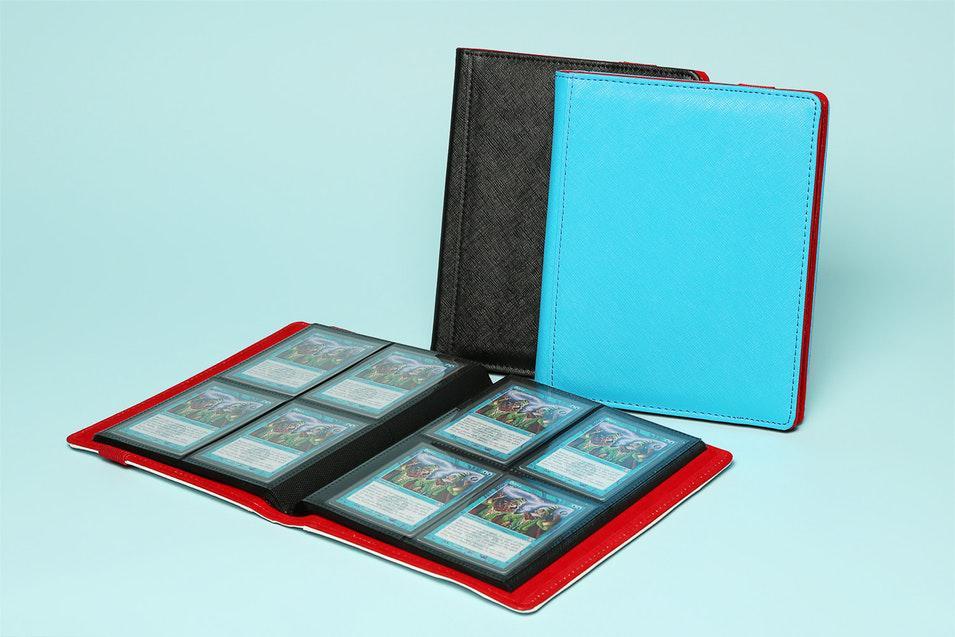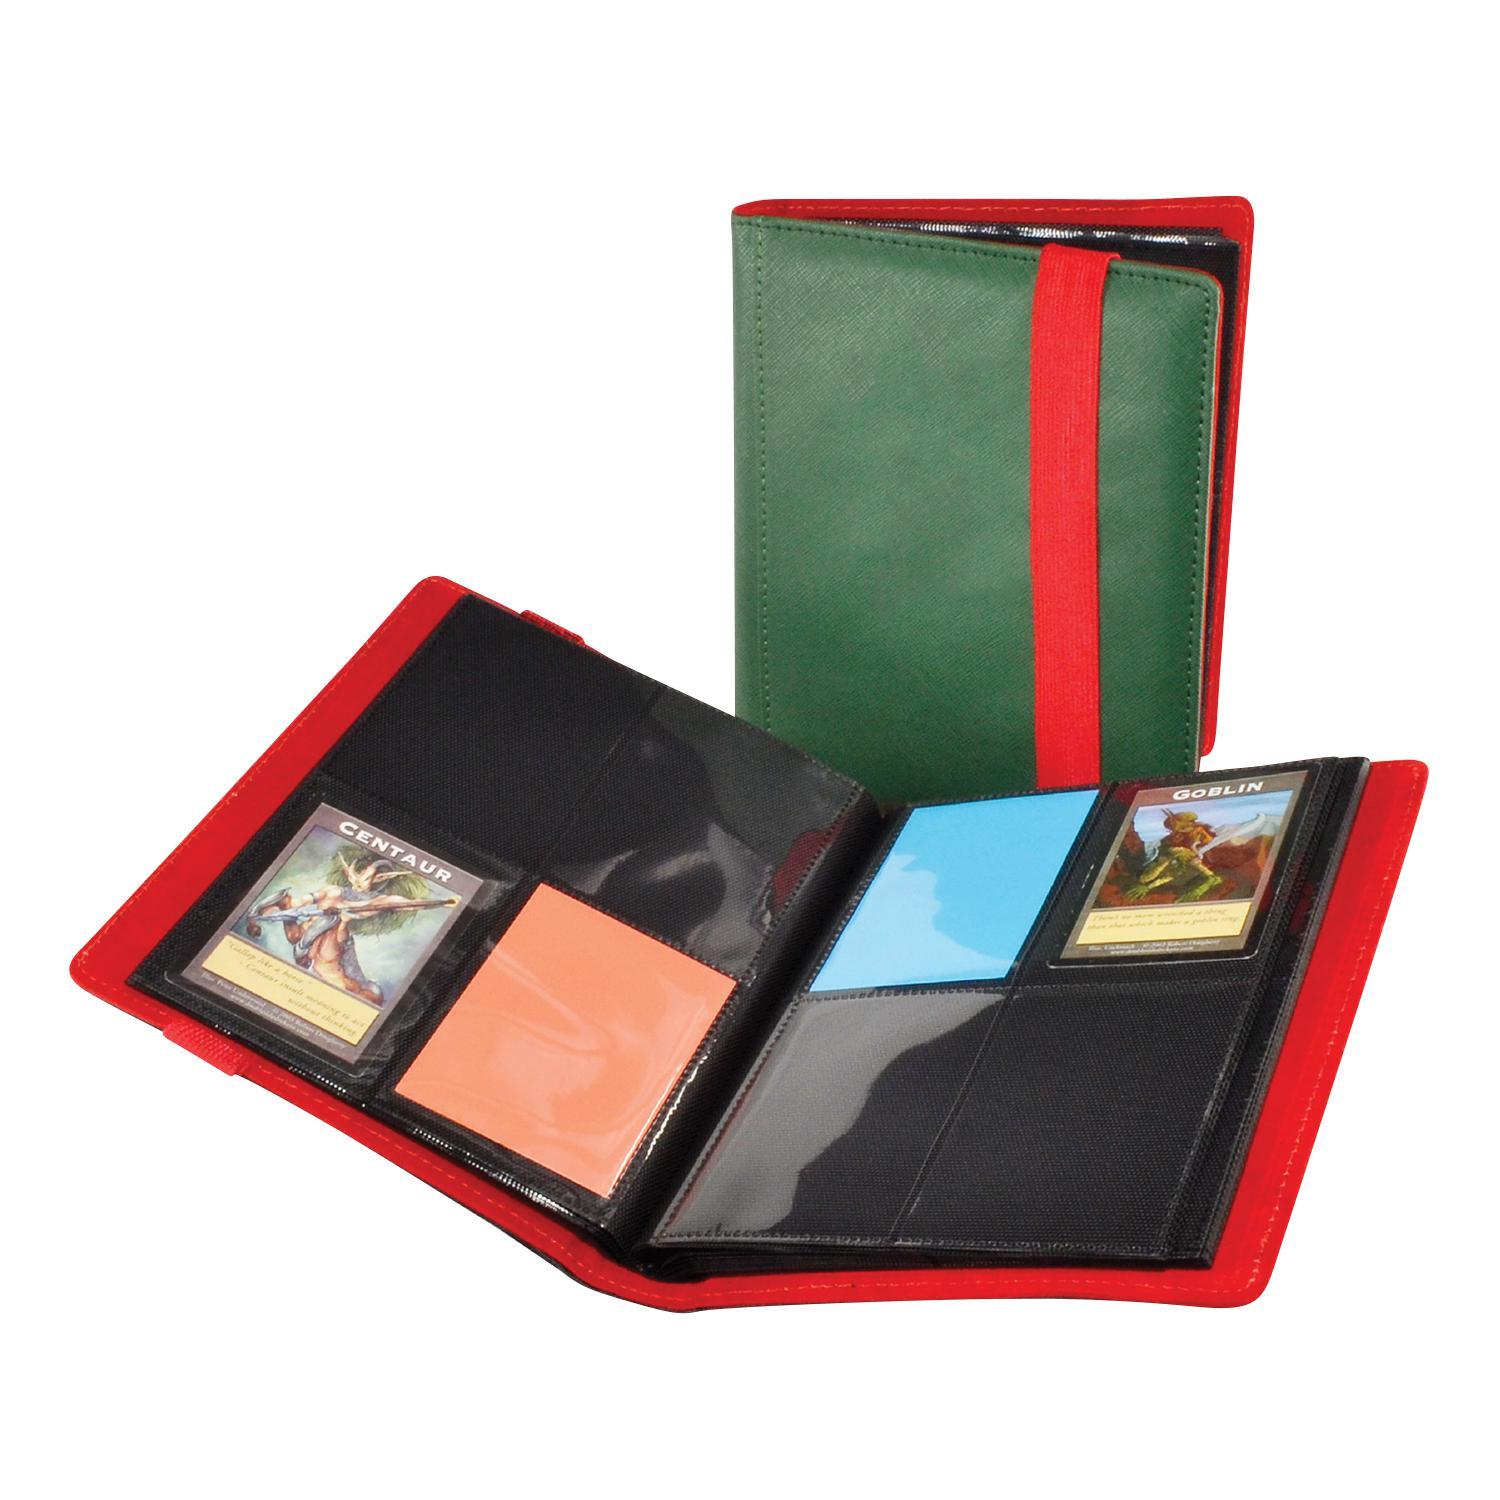The first image is the image on the left, the second image is the image on the right. Evaluate the accuracy of this statement regarding the images: "One binder is bright blue.". Is it true? Answer yes or no. Yes. 